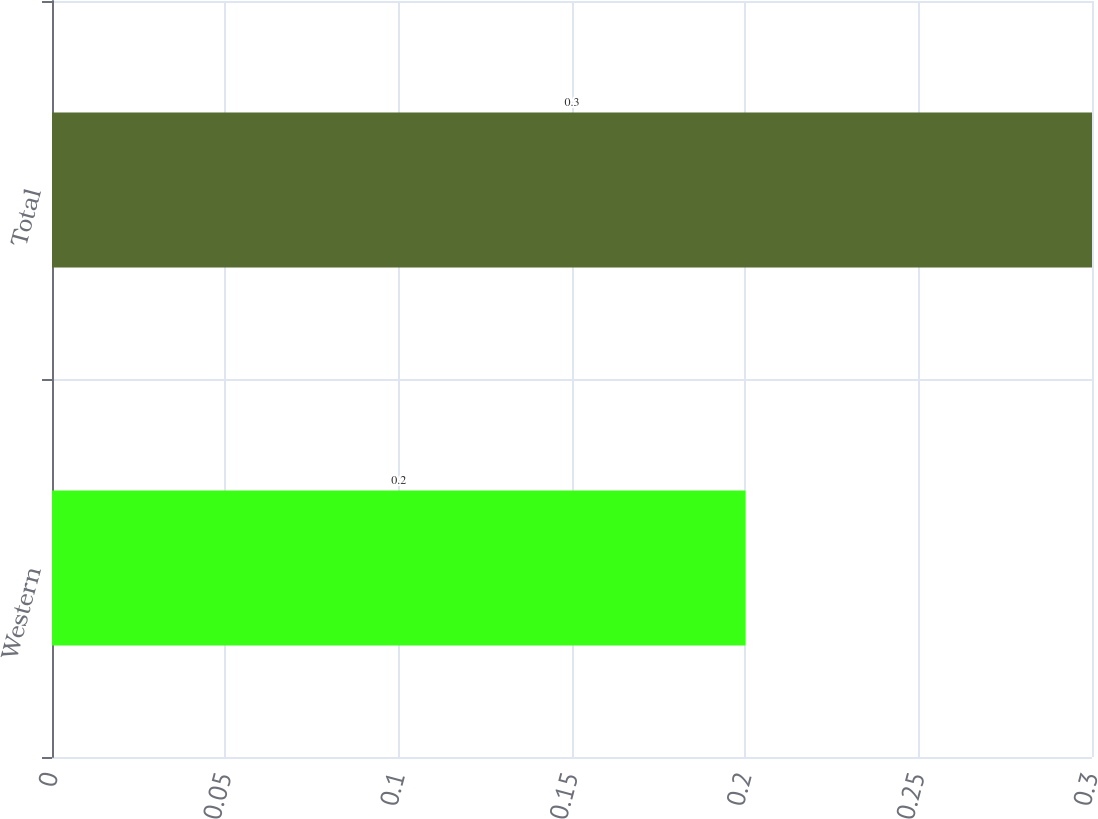<chart> <loc_0><loc_0><loc_500><loc_500><bar_chart><fcel>Western<fcel>Total<nl><fcel>0.2<fcel>0.3<nl></chart> 